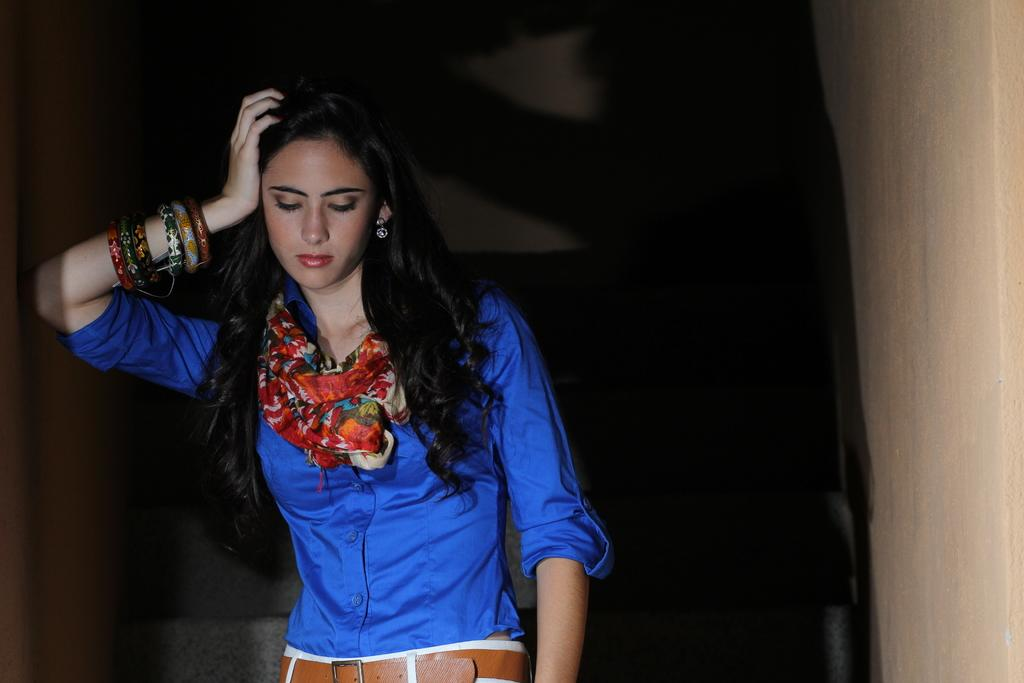Who is present in the image? There is a woman in the image. What is located behind the woman? There is a wall in the image. How would you describe the lighting in the image? The background of the image is dark. What type of horn can be seen on the boy's head in the image? There is no boy or horn present in the image; it only features a woman. 